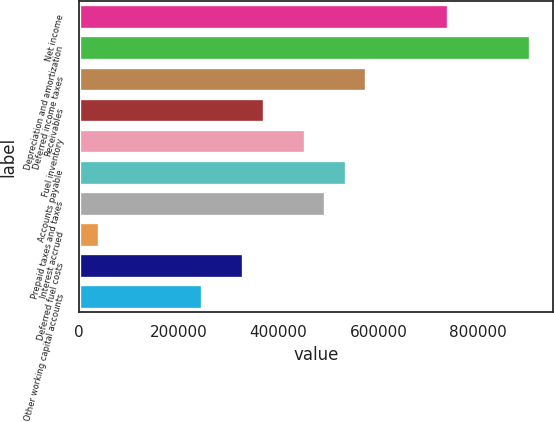Convert chart. <chart><loc_0><loc_0><loc_500><loc_500><bar_chart><fcel>Net income<fcel>Depreciation and amortization<fcel>Deferred income taxes<fcel>Receivables<fcel>Fuel inventory<fcel>Accounts payable<fcel>Prepaid taxes and taxes<fcel>Interest accrued<fcel>Deferred fuel costs<fcel>Other working capital accounts<nl><fcel>739557<fcel>903851<fcel>575262<fcel>369894<fcel>452042<fcel>534189<fcel>493115<fcel>41305.6<fcel>328821<fcel>246674<nl></chart> 